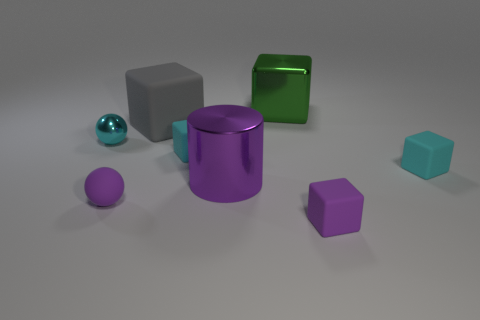Subtract all gray cubes. How many cubes are left? 4 Subtract all gray rubber cubes. How many cubes are left? 4 Subtract all red cubes. Subtract all cyan balls. How many cubes are left? 5 Add 1 tiny red metallic cylinders. How many objects exist? 9 Subtract all cylinders. How many objects are left? 7 Subtract all big gray cubes. Subtract all big green objects. How many objects are left? 6 Add 3 small metal things. How many small metal things are left? 4 Add 3 green metallic balls. How many green metallic balls exist? 3 Subtract 0 blue balls. How many objects are left? 8 